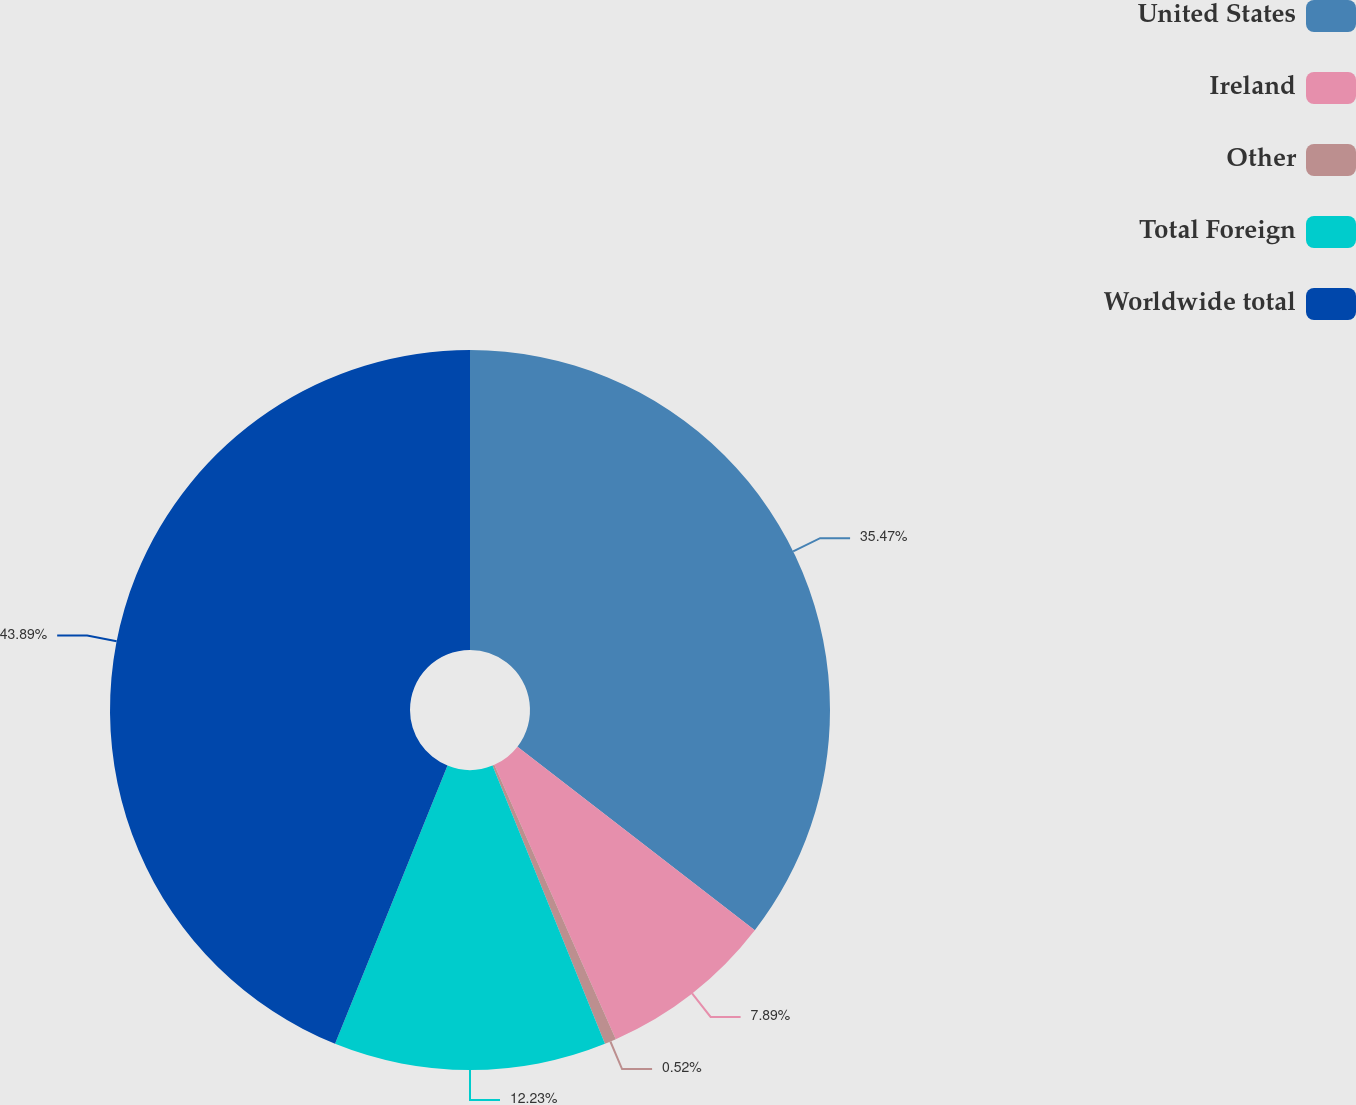<chart> <loc_0><loc_0><loc_500><loc_500><pie_chart><fcel>United States<fcel>Ireland<fcel>Other<fcel>Total Foreign<fcel>Worldwide total<nl><fcel>35.47%<fcel>7.89%<fcel>0.52%<fcel>12.23%<fcel>43.88%<nl></chart> 